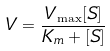<formula> <loc_0><loc_0><loc_500><loc_500>V = \frac { V _ { \max } [ S ] } { K _ { m } + [ S ] }</formula> 